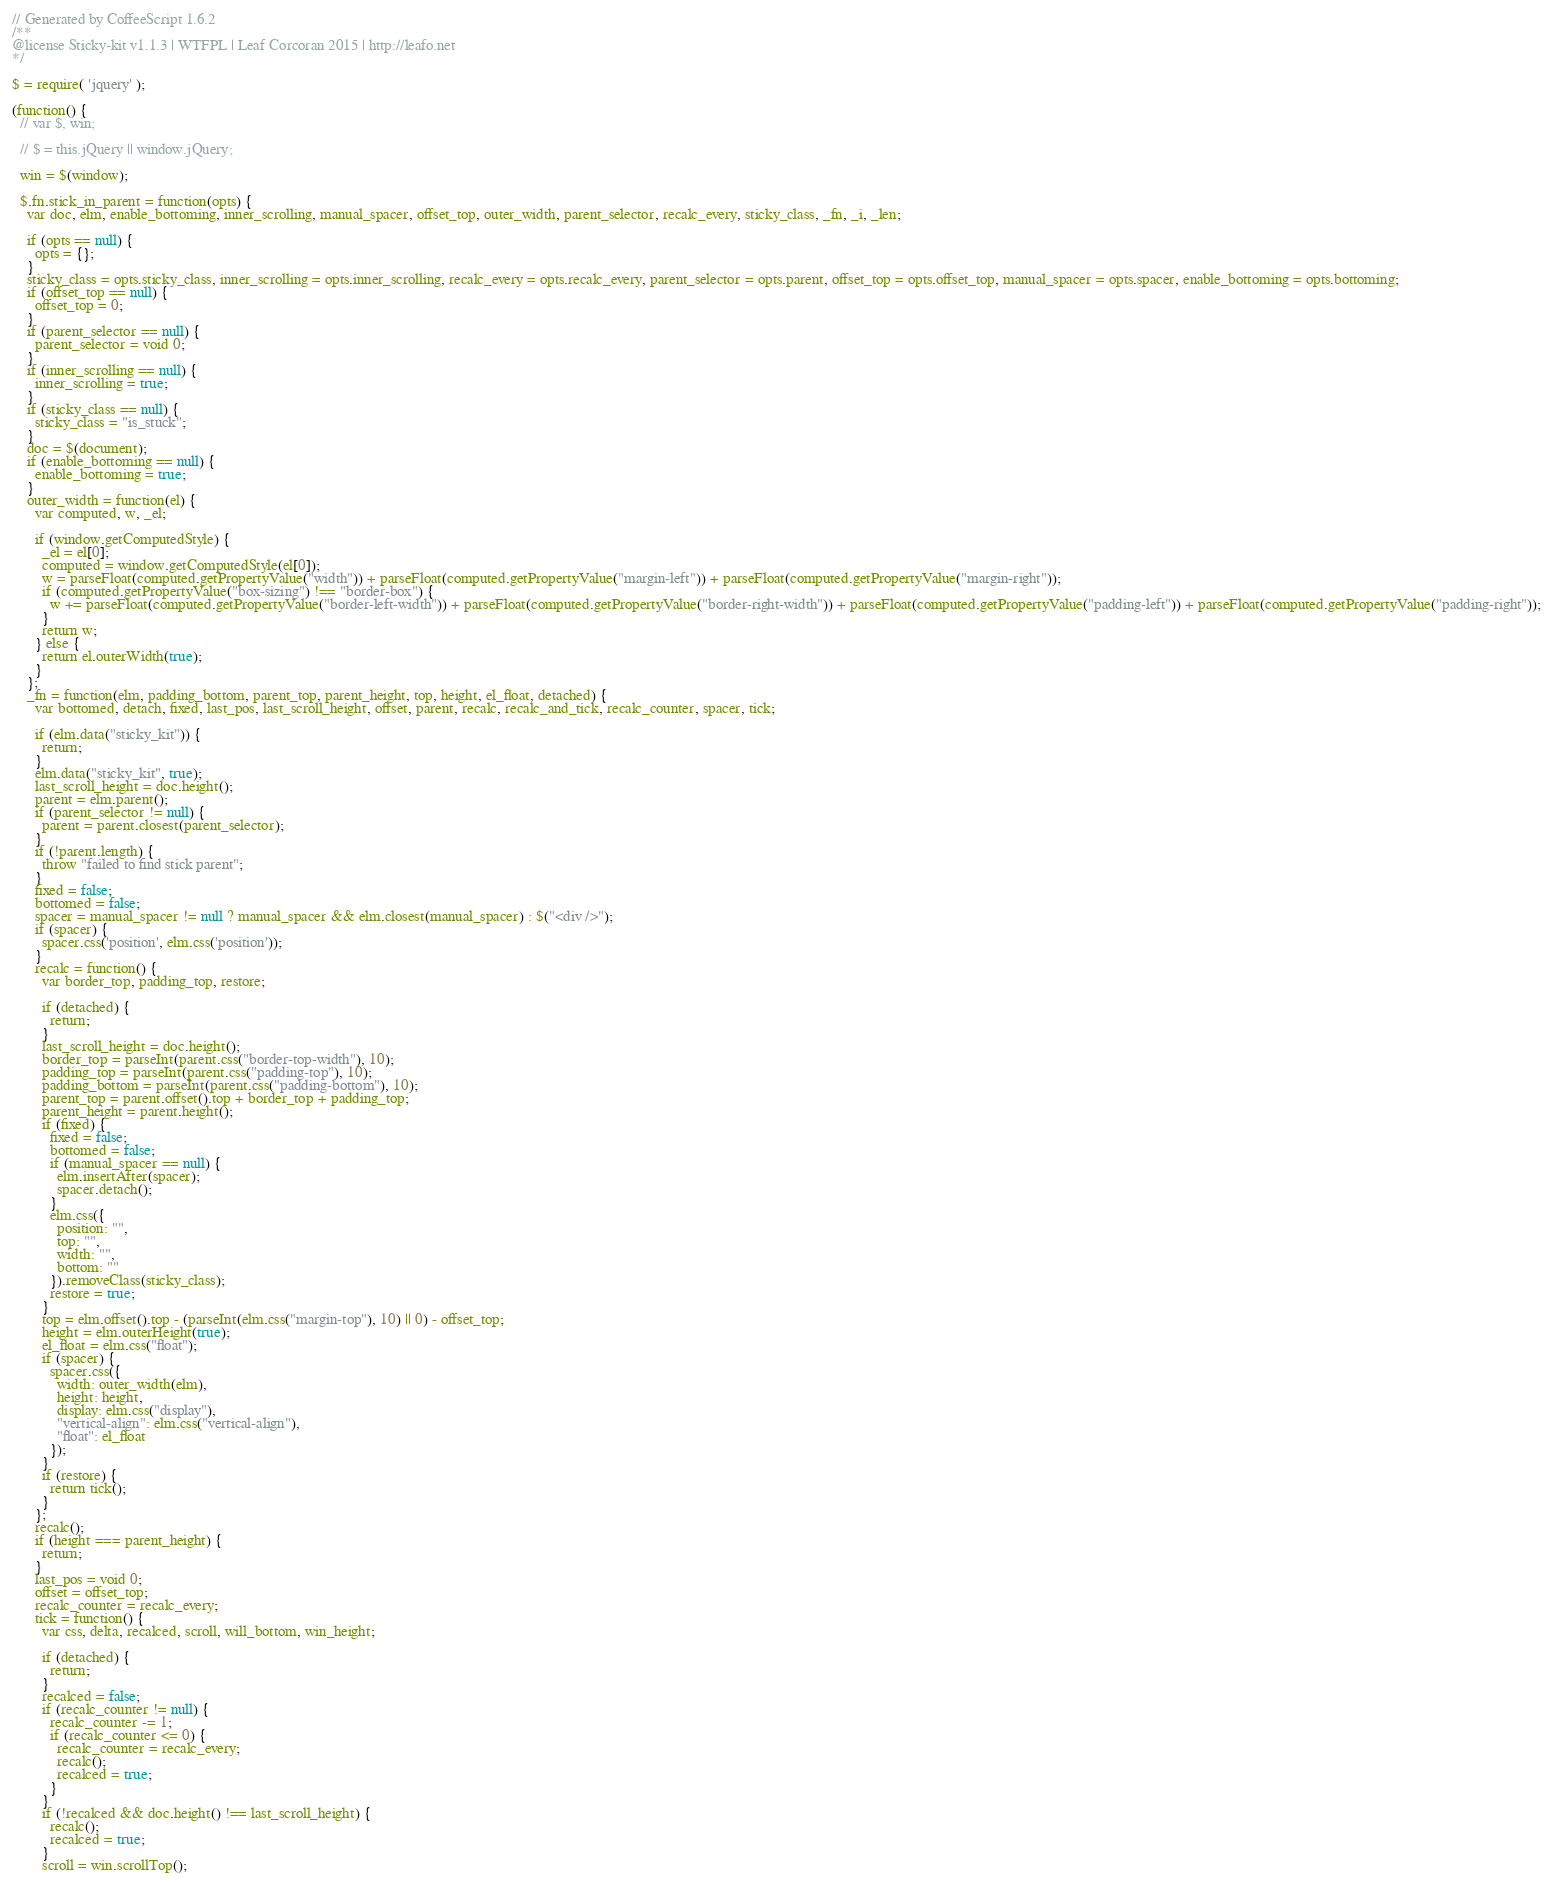Convert code to text. <code><loc_0><loc_0><loc_500><loc_500><_JavaScript_>// Generated by CoffeeScript 1.6.2
/**
@license Sticky-kit v1.1.3 | WTFPL | Leaf Corcoran 2015 | http://leafo.net
*/

$ = require( 'jquery' );

(function() {
  // var $, win;

  // $ = this.jQuery || window.jQuery;

  win = $(window);

  $.fn.stick_in_parent = function(opts) {
    var doc, elm, enable_bottoming, inner_scrolling, manual_spacer, offset_top, outer_width, parent_selector, recalc_every, sticky_class, _fn, _i, _len;

    if (opts == null) {
      opts = {};
    }
    sticky_class = opts.sticky_class, inner_scrolling = opts.inner_scrolling, recalc_every = opts.recalc_every, parent_selector = opts.parent, offset_top = opts.offset_top, manual_spacer = opts.spacer, enable_bottoming = opts.bottoming;
    if (offset_top == null) {
      offset_top = 0;
    }
    if (parent_selector == null) {
      parent_selector = void 0;
    }
    if (inner_scrolling == null) {
      inner_scrolling = true;
    }
    if (sticky_class == null) {
      sticky_class = "is_stuck";
    }
    doc = $(document);
    if (enable_bottoming == null) {
      enable_bottoming = true;
    }
    outer_width = function(el) {
      var computed, w, _el;

      if (window.getComputedStyle) {
        _el = el[0];
        computed = window.getComputedStyle(el[0]);
        w = parseFloat(computed.getPropertyValue("width")) + parseFloat(computed.getPropertyValue("margin-left")) + parseFloat(computed.getPropertyValue("margin-right"));
        if (computed.getPropertyValue("box-sizing") !== "border-box") {
          w += parseFloat(computed.getPropertyValue("border-left-width")) + parseFloat(computed.getPropertyValue("border-right-width")) + parseFloat(computed.getPropertyValue("padding-left")) + parseFloat(computed.getPropertyValue("padding-right"));
        }
        return w;
      } else {
        return el.outerWidth(true);
      }
    };
    _fn = function(elm, padding_bottom, parent_top, parent_height, top, height, el_float, detached) {
      var bottomed, detach, fixed, last_pos, last_scroll_height, offset, parent, recalc, recalc_and_tick, recalc_counter, spacer, tick;

      if (elm.data("sticky_kit")) {
        return;
      }
      elm.data("sticky_kit", true);
      last_scroll_height = doc.height();
      parent = elm.parent();
      if (parent_selector != null) {
        parent = parent.closest(parent_selector);
      }
      if (!parent.length) {
        throw "failed to find stick parent";
      }
      fixed = false;
      bottomed = false;
      spacer = manual_spacer != null ? manual_spacer && elm.closest(manual_spacer) : $("<div />");
      if (spacer) {
        spacer.css('position', elm.css('position'));
      }
      recalc = function() {
        var border_top, padding_top, restore;

        if (detached) {
          return;
        }
        last_scroll_height = doc.height();
        border_top = parseInt(parent.css("border-top-width"), 10);
        padding_top = parseInt(parent.css("padding-top"), 10);
        padding_bottom = parseInt(parent.css("padding-bottom"), 10);
        parent_top = parent.offset().top + border_top + padding_top;
        parent_height = parent.height();
        if (fixed) {
          fixed = false;
          bottomed = false;
          if (manual_spacer == null) {
            elm.insertAfter(spacer);
            spacer.detach();
          }
          elm.css({
            position: "",
            top: "",
            width: "",
            bottom: ""
          }).removeClass(sticky_class);
          restore = true;
        }
        top = elm.offset().top - (parseInt(elm.css("margin-top"), 10) || 0) - offset_top;
        height = elm.outerHeight(true);
        el_float = elm.css("float");
        if (spacer) {
          spacer.css({
            width: outer_width(elm),
            height: height,
            display: elm.css("display"),
            "vertical-align": elm.css("vertical-align"),
            "float": el_float
          });
        }
        if (restore) {
          return tick();
        }
      };
      recalc();
      if (height === parent_height) {
        return;
      }
      last_pos = void 0;
      offset = offset_top;
      recalc_counter = recalc_every;
      tick = function() {
        var css, delta, recalced, scroll, will_bottom, win_height;

        if (detached) {
          return;
        }
        recalced = false;
        if (recalc_counter != null) {
          recalc_counter -= 1;
          if (recalc_counter <= 0) {
            recalc_counter = recalc_every;
            recalc();
            recalced = true;
          }
        }
        if (!recalced && doc.height() !== last_scroll_height) {
          recalc();
          recalced = true;
        }
        scroll = win.scrollTop();</code> 